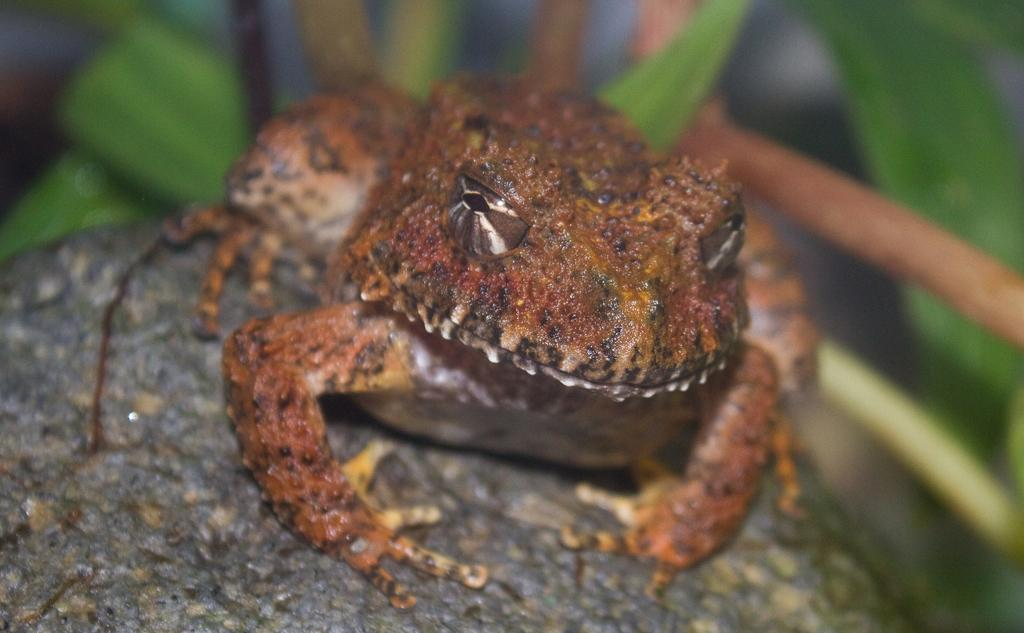What type of animal is in the image? There is a frog in the image. What color is the frog? The frog is brown in color. What else can be seen in the image besides the frog? There are leaves visible in the image. What type of flame can be seen in the image? There is no flame present in the image; it features a brown frog and leaves. 